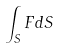Convert formula to latex. <formula><loc_0><loc_0><loc_500><loc_500>\int _ { S } F d S</formula> 